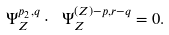<formula> <loc_0><loc_0><loc_500><loc_500>\ \Psi _ { Z } ^ { p _ { 2 } , q } \cdot \ \Psi _ { Z } ^ { ( Z ) - p , r - q } = 0 .</formula> 